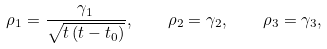<formula> <loc_0><loc_0><loc_500><loc_500>\rho _ { 1 } = \frac { \gamma _ { 1 } } { \sqrt { t \left ( t - t _ { 0 } \right ) } } , \quad \rho _ { 2 } = \gamma _ { 2 } , \quad \rho _ { 3 } = \gamma _ { 3 } ,</formula> 